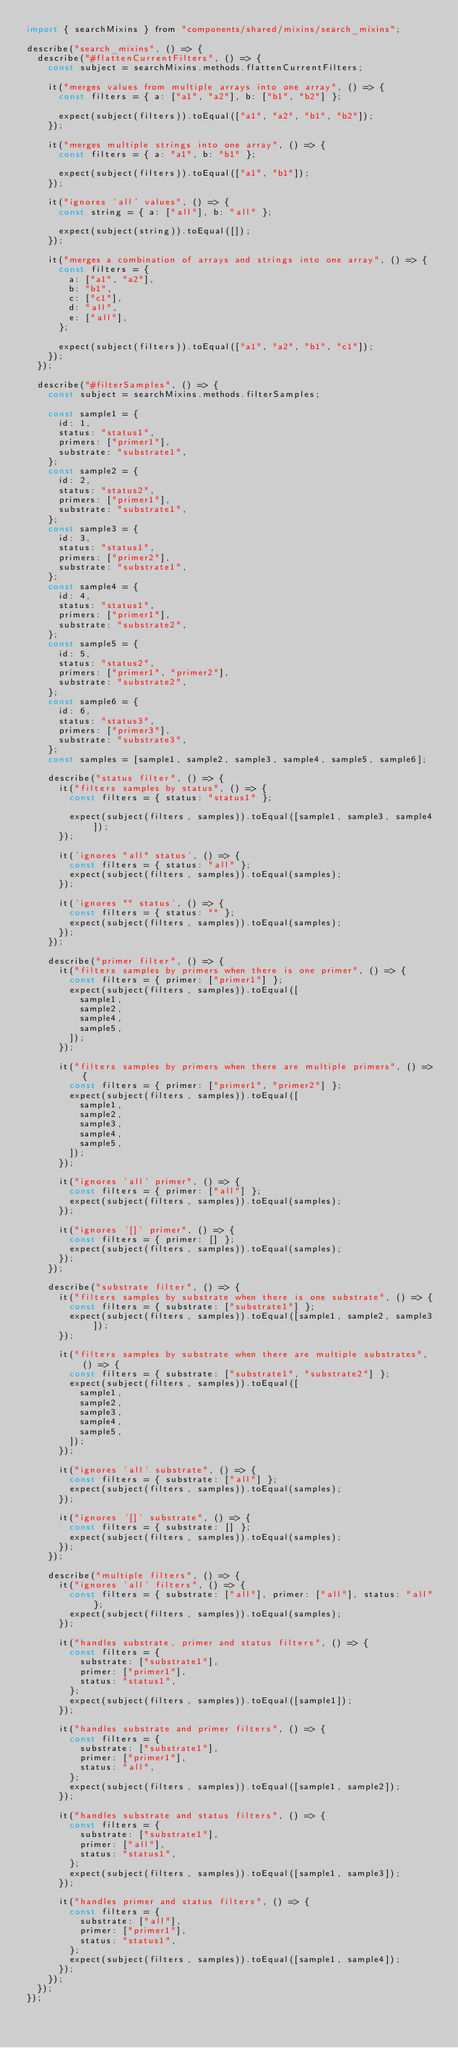Convert code to text. <code><loc_0><loc_0><loc_500><loc_500><_JavaScript_>import { searchMixins } from "components/shared/mixins/search_mixins";

describe("search_mixins", () => {
  describe("#flattenCurrentFilters", () => {
    const subject = searchMixins.methods.flattenCurrentFilters;

    it("merges values from multiple arrays into one array", () => {
      const filters = { a: ["a1", "a2"], b: ["b1", "b2"] };

      expect(subject(filters)).toEqual(["a1", "a2", "b1", "b2"]);
    });

    it("merges multiple strings into one array", () => {
      const filters = { a: "a1", b: "b1" };

      expect(subject(filters)).toEqual(["a1", "b1"]);
    });

    it("ignores 'all' values", () => {
      const string = { a: ["all"], b: "all" };

      expect(subject(string)).toEqual([]);
    });

    it("merges a combination of arrays and strings into one array", () => {
      const filters = {
        a: ["a1", "a2"],
        b: "b1",
        c: ["c1"],
        d: "all",
        e: ["all"],
      };

      expect(subject(filters)).toEqual(["a1", "a2", "b1", "c1"]);
    });
  });

  describe("#filterSamples", () => {
    const subject = searchMixins.methods.filterSamples;

    const sample1 = {
      id: 1,
      status: "status1",
      primers: ["primer1"],
      substrate: "substrate1",
    };
    const sample2 = {
      id: 2,
      status: "status2",
      primers: ["primer1"],
      substrate: "substrate1",
    };
    const sample3 = {
      id: 3,
      status: "status1",
      primers: ["primer2"],
      substrate: "substrate1",
    };
    const sample4 = {
      id: 4,
      status: "status1",
      primers: ["primer1"],
      substrate: "substrate2",
    };
    const sample5 = {
      id: 5,
      status: "status2",
      primers: ["primer1", "primer2"],
      substrate: "substrate2",
    };
    const sample6 = {
      id: 6,
      status: "status3",
      primers: ["primer3"],
      substrate: "substrate3",
    };
    const samples = [sample1, sample2, sample3, sample4, sample5, sample6];

    describe("status filter", () => {
      it("filters samples by status", () => {
        const filters = { status: "status1" };

        expect(subject(filters, samples)).toEqual([sample1, sample3, sample4]);
      });

      it('ignores "all" status', () => {
        const filters = { status: "all" };
        expect(subject(filters, samples)).toEqual(samples);
      });

      it('ignores "" status', () => {
        const filters = { status: "" };
        expect(subject(filters, samples)).toEqual(samples);
      });
    });

    describe("primer filter", () => {
      it("filters samples by primers when there is one primer", () => {
        const filters = { primer: ["primer1"] };
        expect(subject(filters, samples)).toEqual([
          sample1,
          sample2,
          sample4,
          sample5,
        ]);
      });

      it("filters samples by primers when there are multiple primers", () => {
        const filters = { primer: ["primer1", "primer2"] };
        expect(subject(filters, samples)).toEqual([
          sample1,
          sample2,
          sample3,
          sample4,
          sample5,
        ]);
      });

      it("ignores 'all' primer", () => {
        const filters = { primer: ["all"] };
        expect(subject(filters, samples)).toEqual(samples);
      });

      it("ignores '[]' primer", () => {
        const filters = { primer: [] };
        expect(subject(filters, samples)).toEqual(samples);
      });
    });

    describe("substrate filter", () => {
      it("filters samples by substrate when there is one substrate", () => {
        const filters = { substrate: ["substrate1"] };
        expect(subject(filters, samples)).toEqual([sample1, sample2, sample3]);
      });

      it("filters samples by substrate when there are multiple substrates", () => {
        const filters = { substrate: ["substrate1", "substrate2"] };
        expect(subject(filters, samples)).toEqual([
          sample1,
          sample2,
          sample3,
          sample4,
          sample5,
        ]);
      });

      it("ignores 'all' substrate", () => {
        const filters = { substrate: ["all"] };
        expect(subject(filters, samples)).toEqual(samples);
      });

      it("ignores '[]' substrate", () => {
        const filters = { substrate: [] };
        expect(subject(filters, samples)).toEqual(samples);
      });
    });

    describe("multiple filters", () => {
      it("ignores 'all' filters", () => {
        const filters = { substrate: ["all"], primer: ["all"], status: "all" };
        expect(subject(filters, samples)).toEqual(samples);
      });

      it("handles substrate, primer and status filters", () => {
        const filters = {
          substrate: ["substrate1"],
          primer: ["primer1"],
          status: "status1",
        };
        expect(subject(filters, samples)).toEqual([sample1]);
      });

      it("handles substrate and primer filters", () => {
        const filters = {
          substrate: ["substrate1"],
          primer: ["primer1"],
          status: "all",
        };
        expect(subject(filters, samples)).toEqual([sample1, sample2]);
      });

      it("handles substrate and status filters", () => {
        const filters = {
          substrate: ["substrate1"],
          primer: ["all"],
          status: "status1",
        };
        expect(subject(filters, samples)).toEqual([sample1, sample3]);
      });

      it("handles primer and status filters", () => {
        const filters = {
          substrate: ["all"],
          primer: ["primer1"],
          status: "status1",
        };
        expect(subject(filters, samples)).toEqual([sample1, sample4]);
      });
    });
  });
});
</code> 